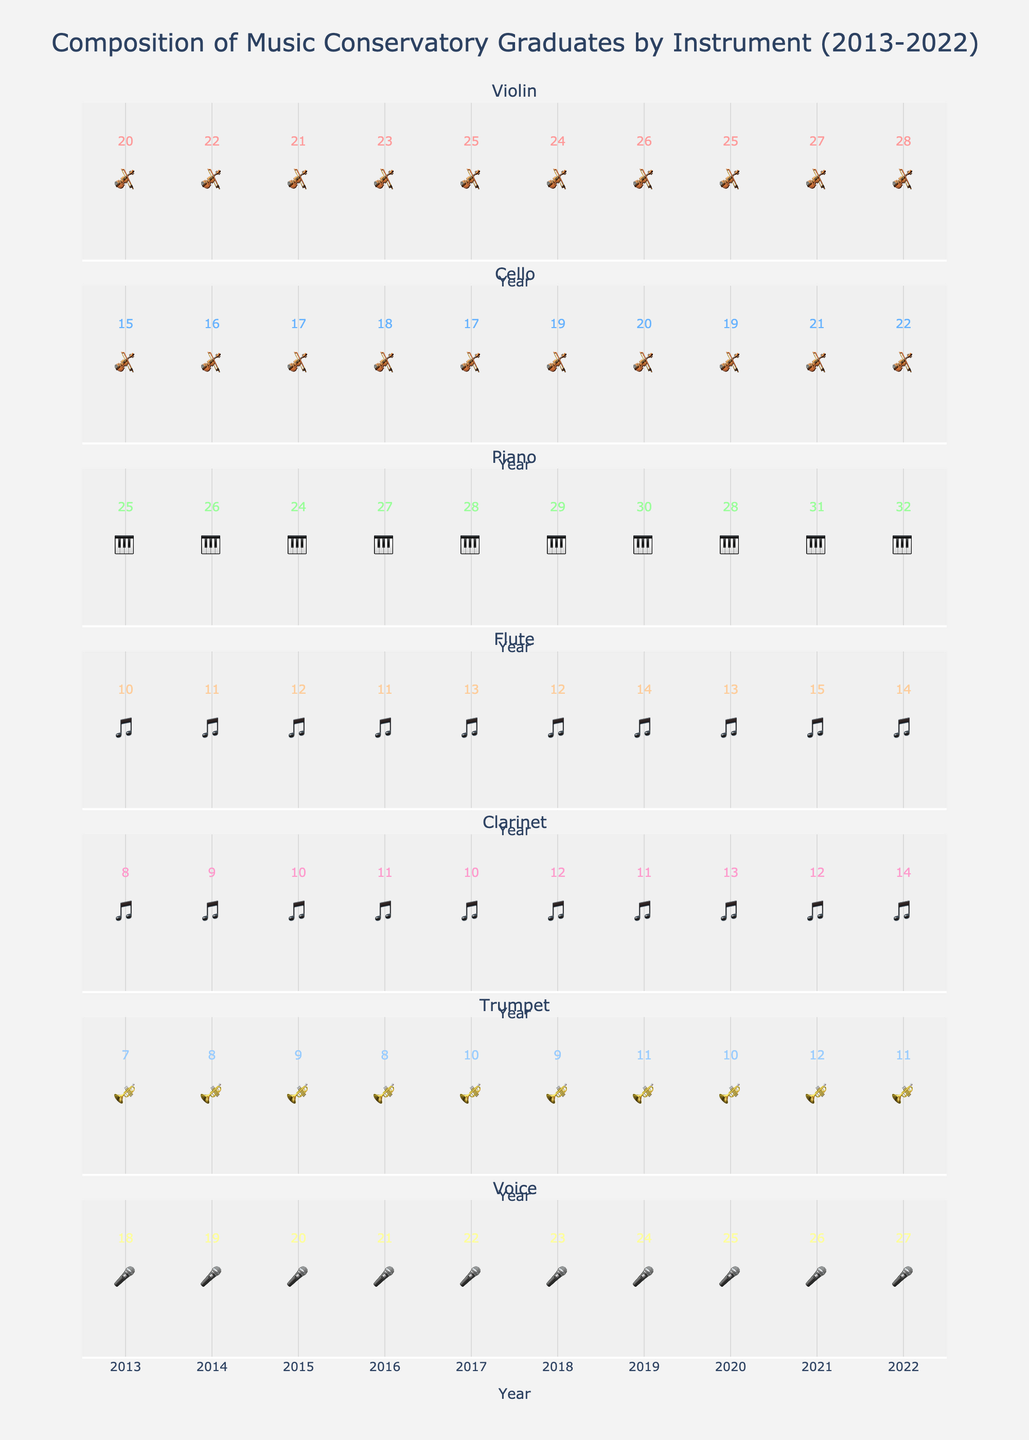What's the subtitle for the first subplot? The first subplot represents Violin graduates and usually subplots are titled by their respective series names, which is "Violin".
Answer: Violin What is the total number of Violin graduates in 2022? The icons in the 2022 column for Violin show a number and each icon represents 5 graduates. The visual and the number indicate the total graduates which is 28.
Answer: 28 How many more Piano graduates were there in 2022 compared to 2013? For Piano, the graduates count in 2022 is shown as 32 and in 2013 it is 25. The difference is 32 - 25 = 7.
Answer: 7 Which instrument had the fewest graduates in 2015? Based on the visual representation and value labels, the instrument with the fewest graduates in 2015 is Trumpet with 9 graduates.
Answer: Trumpet What trend do you observe in the number of Cellists from 2013 to 2022? From the numbers given on the plot, the number of Cellists has generally been increasing each year, from 15 in 2013 to 22 in 2022.
Answer: Increasing Is there any year where the number of Trumpet graduates decreased compared to the previous year? For Trumpet, comparing the values year by year shows that the graduates decreased from 9 in 2015 to 8 in 2016 and from 11 in 2018 to 10 in 2019.
Answer: Yes How many graduates in total specialized in Voice over the decade? Adding the annual numbers from the Voice subplot: 18+19+20+21+22+23+24+25+26+27 = 225
Answer: 225 Which instrument consistently maintained an upward trend over the decade? By observing the number of graduates for each year, Piano consistently shows an increasing trend without any decreases.
Answer: Piano How many graduates were there in total for Flute and Clarinet combined in 2018? From the plot, in 2018, Flute had 12 graduates and Clarinet had 12 graduates as well. The total is 12 + 12 = 24
Answer: 24 Which instrument had the highest increase in the number of graduates from 2013 to 2022? Comparing the different counts, Voice increased from 18 in 2013 to 27 in 2022, which is a change of 27 - 18 = 9, the highest among the given instruments.
Answer: Voice 